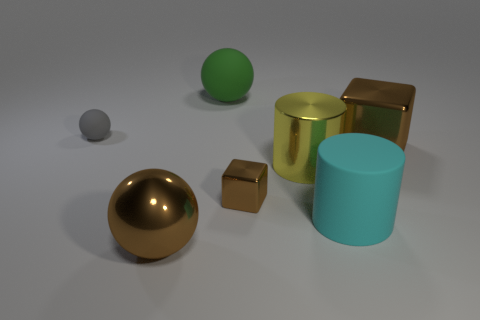There is a big block that is the same color as the small metal object; what is its material? The big block sharing the same color as the small object appears metallic due to its reflective surface and luster, suggesting that it is made of metal, likely a polished gold finish similar to the smaller cube. 